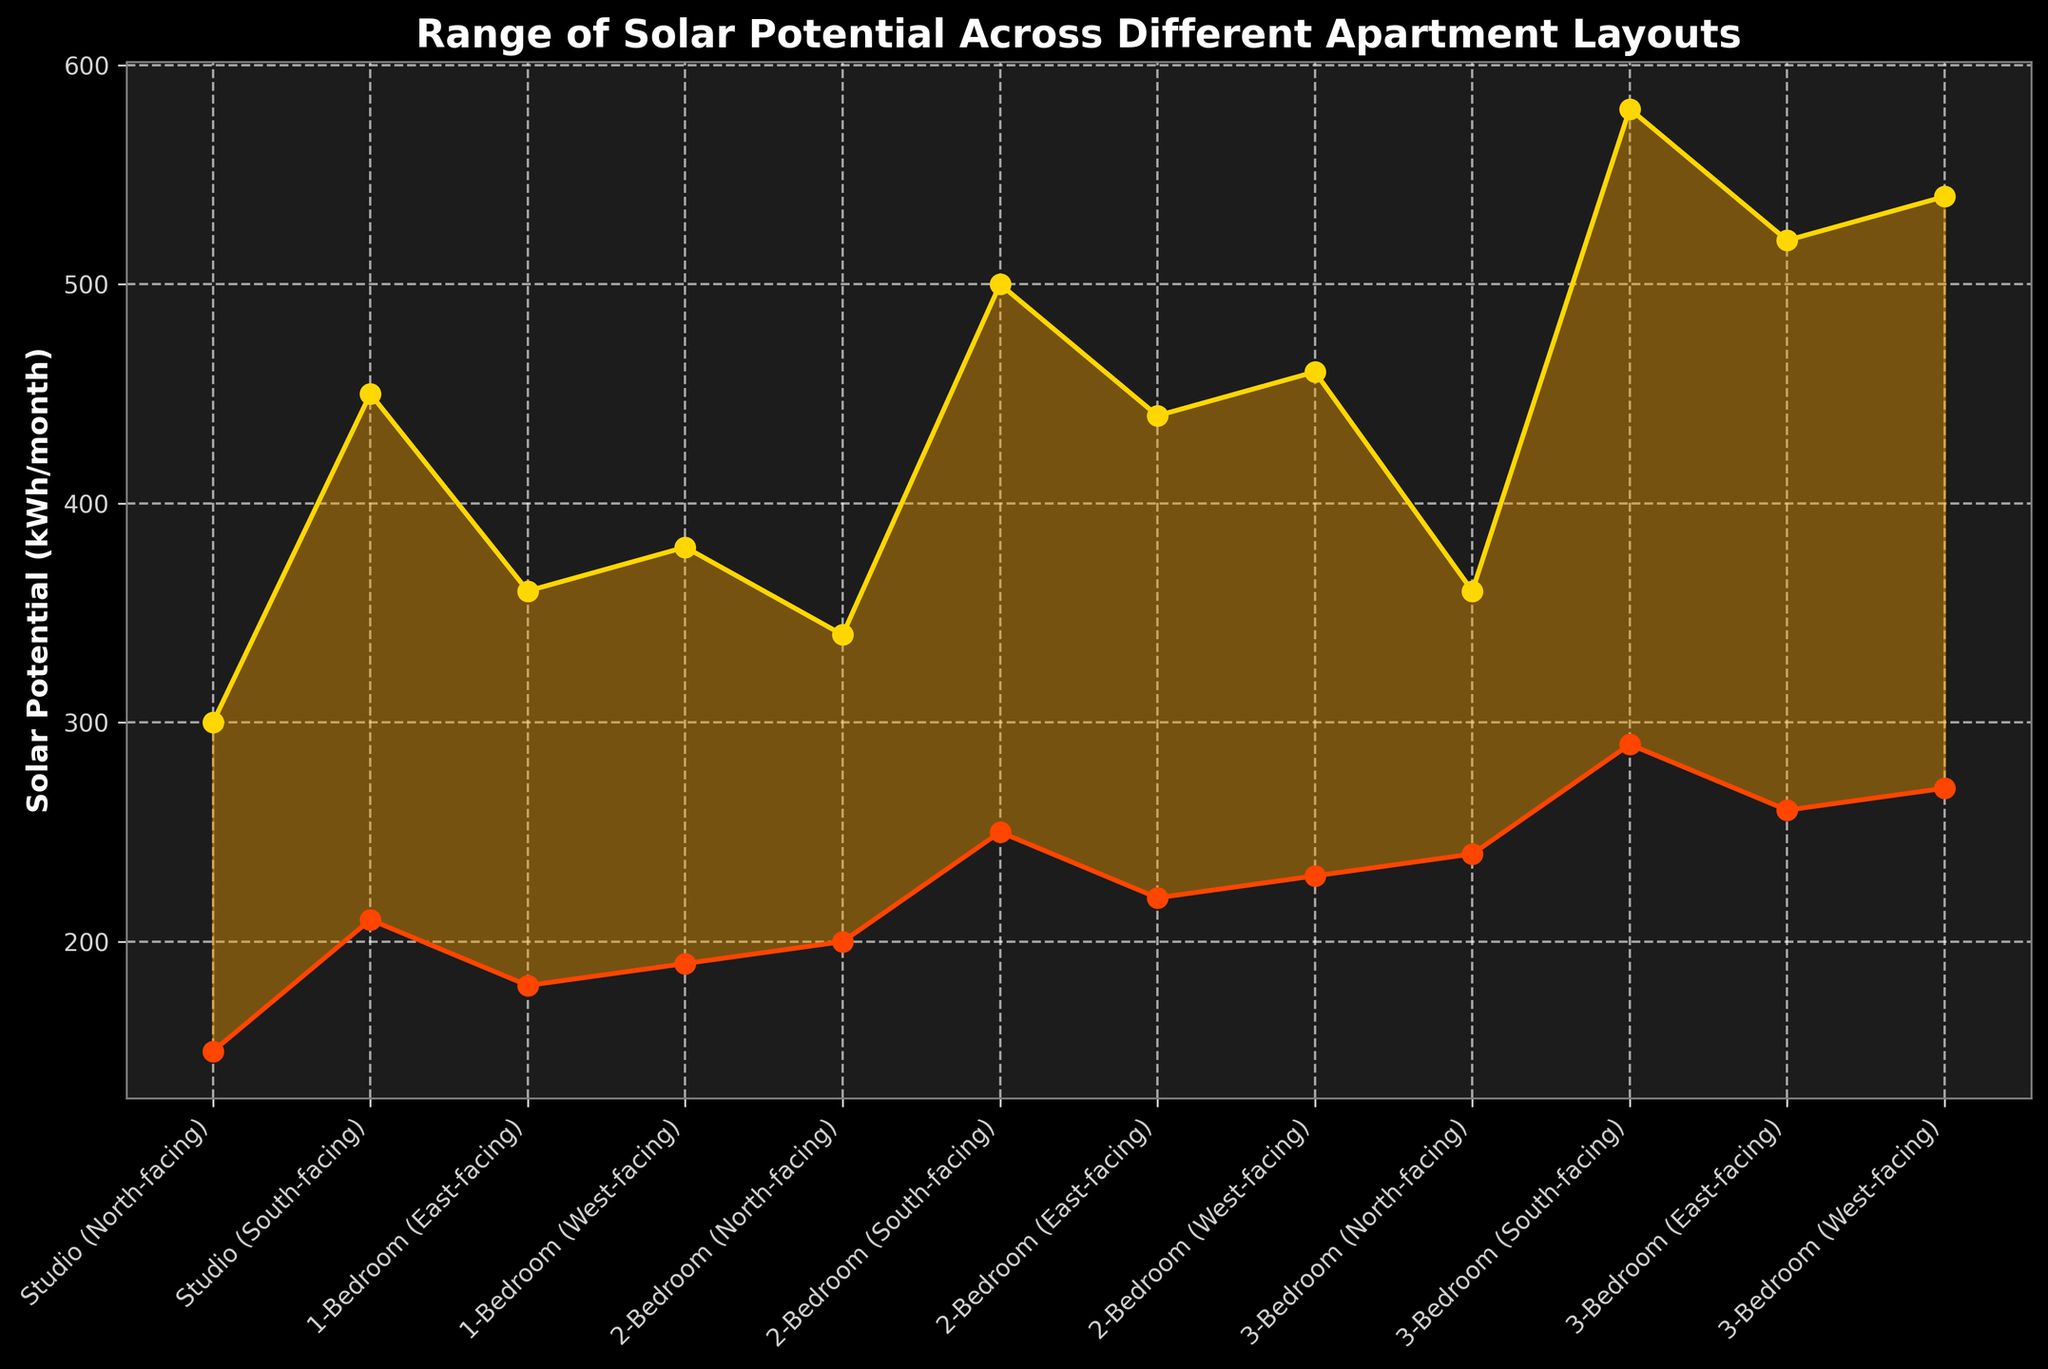What is the title of the figure? The title is usually located at the top of the figure and summarizes the main theme of the chart. In this case, the title reads "Range of Solar Potential Across Different Apartment Layouts."
Answer: Range of Solar Potential Across Different Apartment Layouts Which apartment layout has the highest maximum solar potential? To determine this, look for the highest point in the plot representing maximum solar potential values. The 3-Bedroom (South-facing) apartment layout has the highest maximum value.
Answer: 3-Bedroom (South-facing) What is the minimum solar potential for a Studio (North-facing) layout? Identify the point labeled "Studio (North-facing)" on the x-axis and find its corresponding minimum value, which is indicated by the lower end of the filled area. The value is 150 kWh/month.
Answer: 150 kWh/month How much more maximum solar potential does a Studio (South-facing) have compared to a Studio (North-facing)? Subtract the maximum solar potential of the Studio (North-facing) from that of the Studio (South-facing). 450 - 300 equals 150 kWh/month.
Answer: 150 kWh/month What is the range of solar potential for a 2-Bedroom (East-facing) layout? Calculate the range by subtracting the minimum solar potential from the maximum solar potential for this layout. 440 - 220 equals 220 kWh/month.
Answer: 220 kWh/month Which apartment layout has the smallest difference between its minimum and maximum solar potential? Examine the range (difference between the minimum and maximum solar potential) for each layout. The Studio (North-facing) layout has the smallest range, which is 300 - 150 = 150 kWh/month.
Answer: Studio (North-facing) How does the solar potential range for a 1-Bedroom (East-facing) compare to that of a 1-Bedroom (West-facing)? Compare the ranges of both layouts. For 1-Bedroom (East-facing), the range is 360 - 180 = 180 kWh/month. For 1-Bedroom (West-facing), the range is 380 - 190 = 190 kWh/month. The East-facing layout has a smaller range.
Answer: The East-facing layout has a smaller range Which layout has a higher minimum solar potential, 2-Bedroom (North-facing) or 3-Bedroom (West-facing)? Compare the minimum solar potential values of both layouts; 2-Bedroom (North-facing) has 200, and 3-Bedroom (West-facing) has 270. The 3-Bedroom (West-facing) layout has the higher minimum solar potential.
Answer: 3-Bedroom (West-facing) What is the average of the maximum solar potentials for all Studio layouts? Add the maximum solar potentials for both Studio layouts and divide by 2. (300 + 450) / 2 equals 375 kWh/month.
Answer: 375 kWh/month How does sunlight exposure direction influence the solar potential range for 2-Bedroom apartments? Compare the solar potential ranges for different exposures of 2-Bedroom apartments: North-facing (140), South-facing (250), East-facing (220), and West-facing (230). South-facing has the highest range, indicating greater sunlight exposure impact.
Answer: South-facing has the highest range 